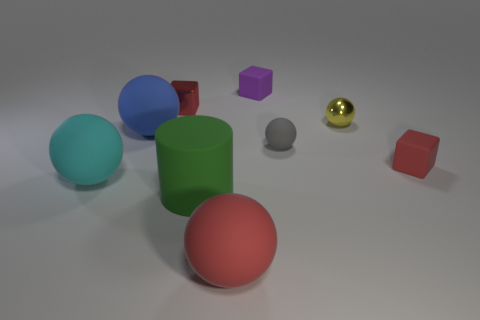Subtract 1 balls. How many balls are left? 4 Subtract all yellow spheres. How many spheres are left? 4 Subtract all blue spheres. How many spheres are left? 4 Subtract all purple balls. Subtract all green cylinders. How many balls are left? 5 Subtract all cubes. How many objects are left? 6 Add 6 small yellow metallic objects. How many small yellow metallic objects are left? 7 Add 4 large red rubber things. How many large red rubber things exist? 5 Subtract 0 yellow cylinders. How many objects are left? 9 Subtract all big green cylinders. Subtract all cyan rubber balls. How many objects are left? 7 